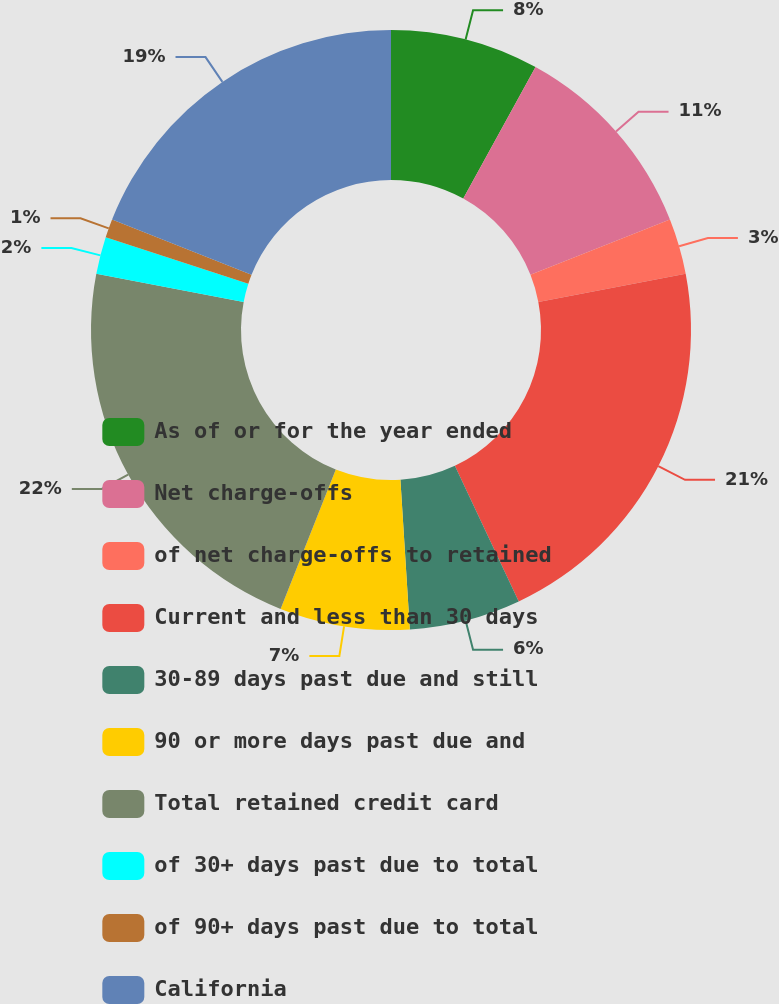Convert chart. <chart><loc_0><loc_0><loc_500><loc_500><pie_chart><fcel>As of or for the year ended<fcel>Net charge-offs<fcel>of net charge-offs to retained<fcel>Current and less than 30 days<fcel>30-89 days past due and still<fcel>90 or more days past due and<fcel>Total retained credit card<fcel>of 30+ days past due to total<fcel>of 90+ days past due to total<fcel>California<nl><fcel>8.0%<fcel>11.0%<fcel>3.0%<fcel>21.0%<fcel>6.0%<fcel>7.0%<fcel>22.0%<fcel>2.0%<fcel>1.0%<fcel>19.0%<nl></chart> 